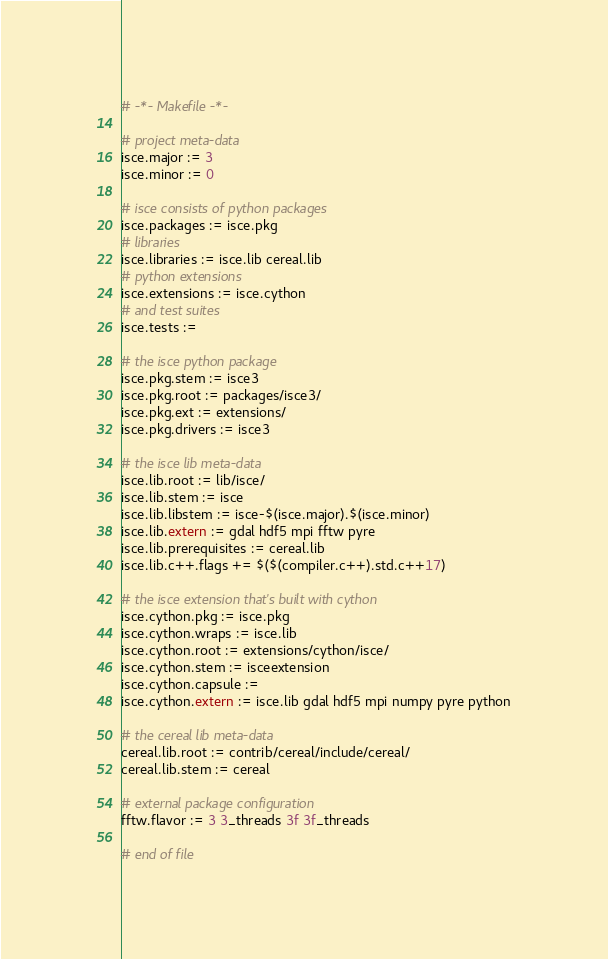Convert code to text. <code><loc_0><loc_0><loc_500><loc_500><_ObjectiveC_># -*- Makefile -*-

# project meta-data
isce.major := 3
isce.minor := 0

# isce consists of python packages
isce.packages := isce.pkg
# libraries
isce.libraries := isce.lib cereal.lib
# python extensions
isce.extensions := isce.cython
# and test suites
isce.tests :=

# the isce python package
isce.pkg.stem := isce3
isce.pkg.root := packages/isce3/
isce.pkg.ext := extensions/
isce.pkg.drivers := isce3

# the isce lib meta-data
isce.lib.root := lib/isce/
isce.lib.stem := isce
isce.lib.libstem := isce-$(isce.major).$(isce.minor)
isce.lib.extern := gdal hdf5 mpi fftw pyre
isce.lib.prerequisites := cereal.lib
isce.lib.c++.flags += $($(compiler.c++).std.c++17)

# the isce extension that's built with cython
isce.cython.pkg := isce.pkg
isce.cython.wraps := isce.lib
isce.cython.root := extensions/cython/isce/
isce.cython.stem := isceextension
isce.cython.capsule :=
isce.cython.extern := isce.lib gdal hdf5 mpi numpy pyre python

# the cereal lib meta-data
cereal.lib.root := contrib/cereal/include/cereal/
cereal.lib.stem := cereal

# external package configuration
fftw.flavor := 3 3_threads 3f 3f_threads

# end of file
</code> 